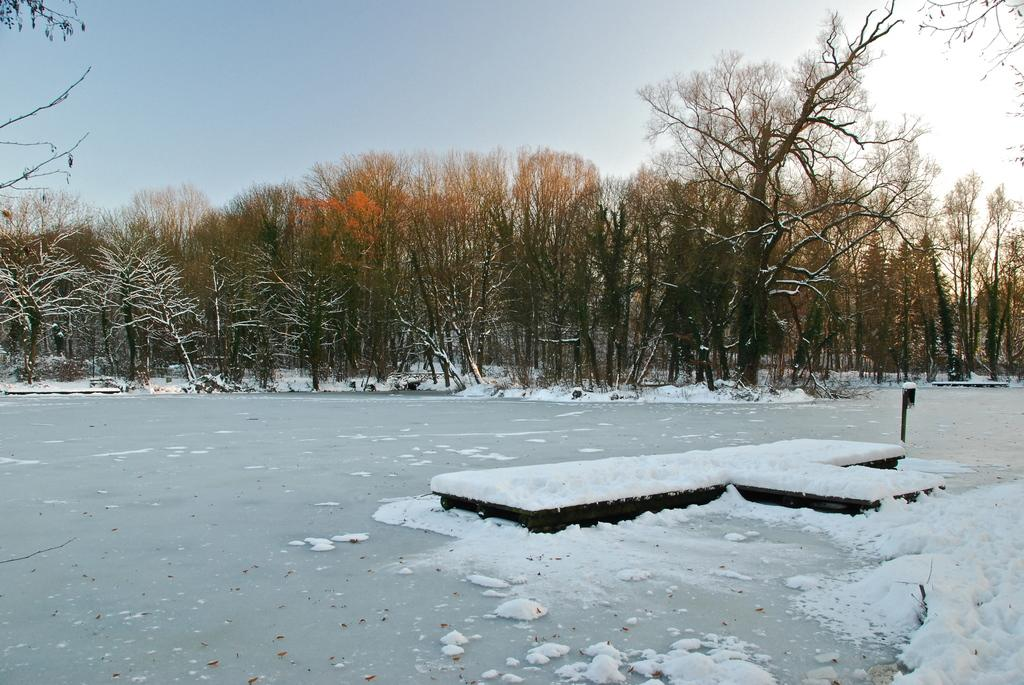What is the condition of the ground in the image? The place in the image is covered with snow. What type of vegetation can be seen in the image? The area is surrounded by trees. What color is the sky in the image? The sky is blue in the image. Can you see any waves in the image? There are no waves present in the image, as it features a snow-covered area surrounded by trees and a blue sky. Are there any people swimming in the image? There are no people swimming in the image, as it features a snow-covered area surrounded by trees and a blue sky. 